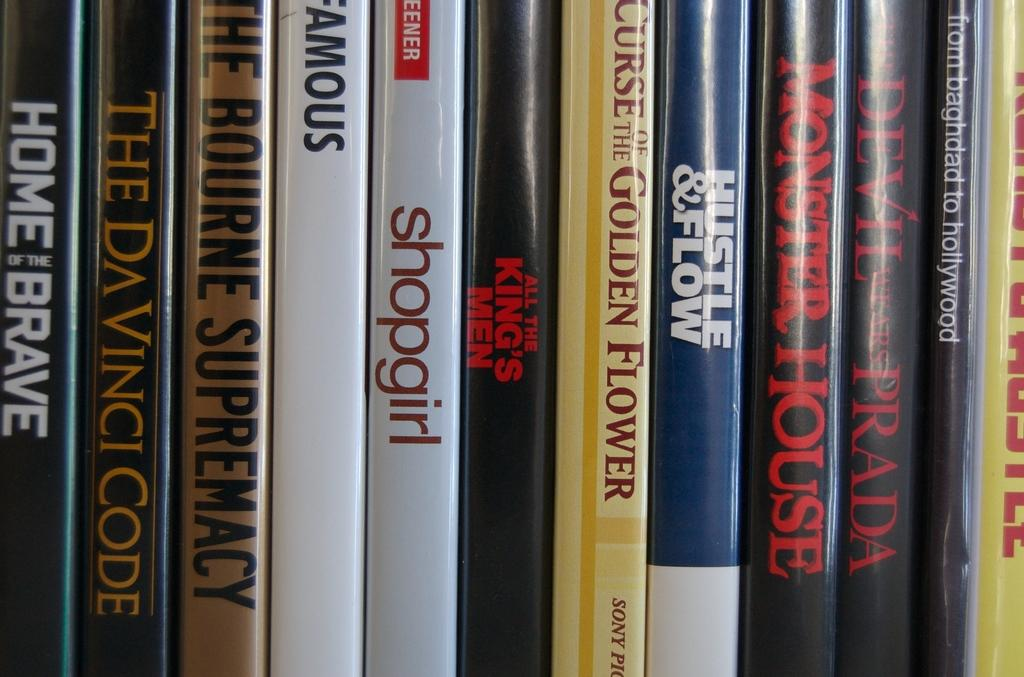<image>
Summarize the visual content of the image. A number of books including Home of the Brave are on a bookshelf. 